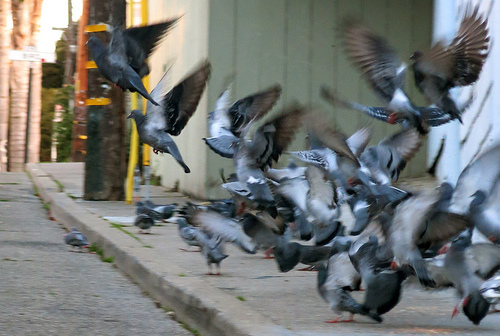<image>
Can you confirm if the bird is on the curb? No. The bird is not positioned on the curb. They may be near each other, but the bird is not supported by or resting on top of the curb. 